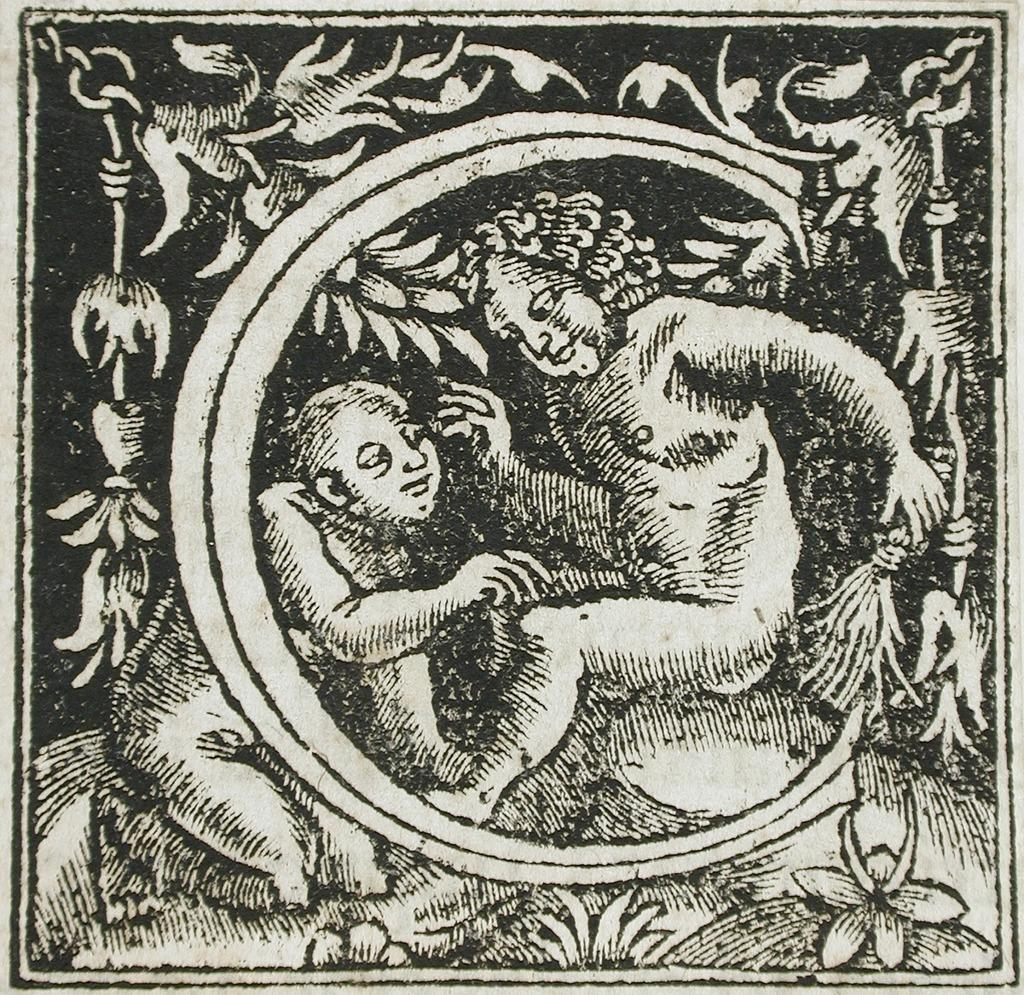What is depicted in the image? The image contains a sketch of two persons sitting. What other elements are present in the sketch? There are flowers and trees in the sketch. What is the color scheme of the image? The image is black and white in color. What type of magic is being performed by the persons in the sketch? There is no indication of magic or any magical elements in the sketch; it simply depicts two persons sitting. What word is written on the trees in the sketch? There are no words present on the trees in the sketch; they are depicted as natural elements. 